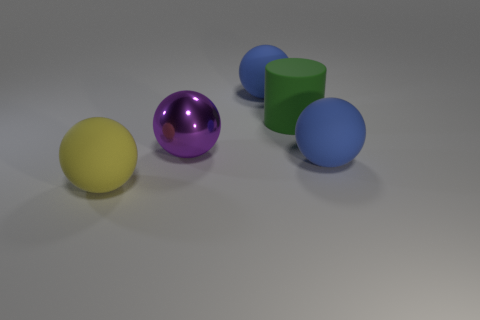Subtract all big yellow matte spheres. How many spheres are left? 3 Add 2 big matte spheres. How many objects exist? 7 Subtract all purple balls. How many balls are left? 3 Subtract 1 cylinders. How many cylinders are left? 0 Subtract all cylinders. How many objects are left? 4 Subtract all brown spheres. How many red cylinders are left? 0 Add 2 gray metallic blocks. How many gray metallic blocks exist? 2 Subtract 1 green cylinders. How many objects are left? 4 Subtract all red spheres. Subtract all red cubes. How many spheres are left? 4 Subtract all large shiny objects. Subtract all large cylinders. How many objects are left? 3 